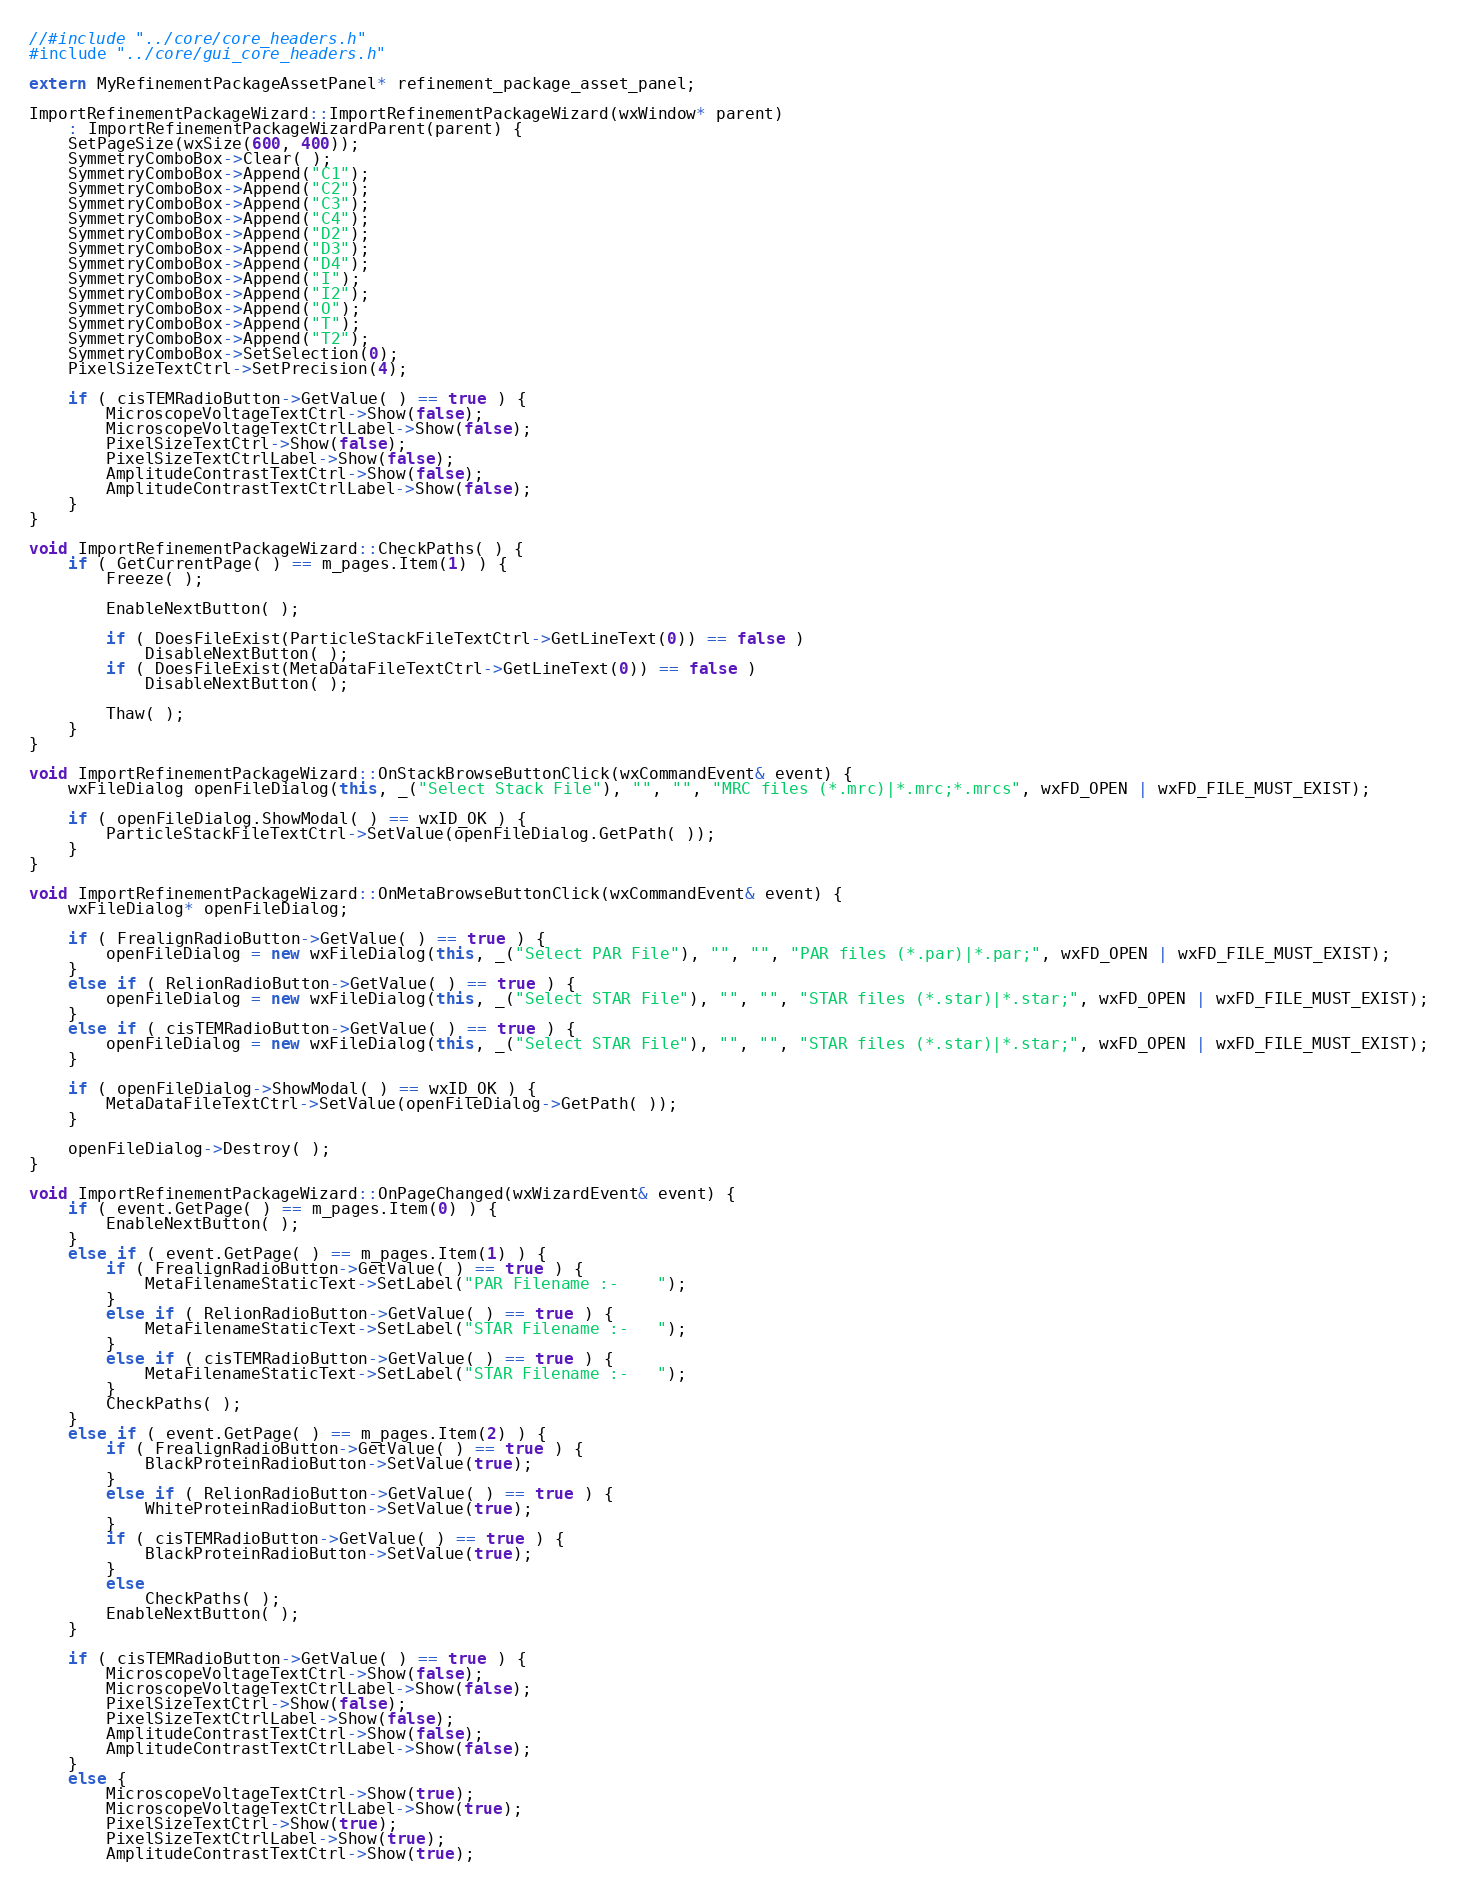Convert code to text. <code><loc_0><loc_0><loc_500><loc_500><_C++_>//#include "../core/core_headers.h"
#include "../core/gui_core_headers.h"

extern MyRefinementPackageAssetPanel* refinement_package_asset_panel;

ImportRefinementPackageWizard::ImportRefinementPackageWizard(wxWindow* parent)
    : ImportRefinementPackageWizardParent(parent) {
    SetPageSize(wxSize(600, 400));
    SymmetryComboBox->Clear( );
    SymmetryComboBox->Append("C1");
    SymmetryComboBox->Append("C2");
    SymmetryComboBox->Append("C3");
    SymmetryComboBox->Append("C4");
    SymmetryComboBox->Append("D2");
    SymmetryComboBox->Append("D3");
    SymmetryComboBox->Append("D4");
    SymmetryComboBox->Append("I");
    SymmetryComboBox->Append("I2");
    SymmetryComboBox->Append("O");
    SymmetryComboBox->Append("T");
    SymmetryComboBox->Append("T2");
    SymmetryComboBox->SetSelection(0);
    PixelSizeTextCtrl->SetPrecision(4);

    if ( cisTEMRadioButton->GetValue( ) == true ) {
        MicroscopeVoltageTextCtrl->Show(false);
        MicroscopeVoltageTextCtrlLabel->Show(false);
        PixelSizeTextCtrl->Show(false);
        PixelSizeTextCtrlLabel->Show(false);
        AmplitudeContrastTextCtrl->Show(false);
        AmplitudeContrastTextCtrlLabel->Show(false);
    }
}

void ImportRefinementPackageWizard::CheckPaths( ) {
    if ( GetCurrentPage( ) == m_pages.Item(1) ) {
        Freeze( );

        EnableNextButton( );

        if ( DoesFileExist(ParticleStackFileTextCtrl->GetLineText(0)) == false )
            DisableNextButton( );
        if ( DoesFileExist(MetaDataFileTextCtrl->GetLineText(0)) == false )
            DisableNextButton( );

        Thaw( );
    }
}

void ImportRefinementPackageWizard::OnStackBrowseButtonClick(wxCommandEvent& event) {
    wxFileDialog openFileDialog(this, _("Select Stack File"), "", "", "MRC files (*.mrc)|*.mrc;*.mrcs", wxFD_OPEN | wxFD_FILE_MUST_EXIST);

    if ( openFileDialog.ShowModal( ) == wxID_OK ) {
        ParticleStackFileTextCtrl->SetValue(openFileDialog.GetPath( ));
    }
}

void ImportRefinementPackageWizard::OnMetaBrowseButtonClick(wxCommandEvent& event) {
    wxFileDialog* openFileDialog;

    if ( FrealignRadioButton->GetValue( ) == true ) {
        openFileDialog = new wxFileDialog(this, _("Select PAR File"), "", "", "PAR files (*.par)|*.par;", wxFD_OPEN | wxFD_FILE_MUST_EXIST);
    }
    else if ( RelionRadioButton->GetValue( ) == true ) {
        openFileDialog = new wxFileDialog(this, _("Select STAR File"), "", "", "STAR files (*.star)|*.star;", wxFD_OPEN | wxFD_FILE_MUST_EXIST);
    }
    else if ( cisTEMRadioButton->GetValue( ) == true ) {
        openFileDialog = new wxFileDialog(this, _("Select STAR File"), "", "", "STAR files (*.star)|*.star;", wxFD_OPEN | wxFD_FILE_MUST_EXIST);
    }

    if ( openFileDialog->ShowModal( ) == wxID_OK ) {
        MetaDataFileTextCtrl->SetValue(openFileDialog->GetPath( ));
    }

    openFileDialog->Destroy( );
}

void ImportRefinementPackageWizard::OnPageChanged(wxWizardEvent& event) {
    if ( event.GetPage( ) == m_pages.Item(0) ) {
        EnableNextButton( );
    }
    else if ( event.GetPage( ) == m_pages.Item(1) ) {
        if ( FrealignRadioButton->GetValue( ) == true ) {
            MetaFilenameStaticText->SetLabel("PAR Filename :-    ");
        }
        else if ( RelionRadioButton->GetValue( ) == true ) {
            MetaFilenameStaticText->SetLabel("STAR Filename :-   ");
        }
        else if ( cisTEMRadioButton->GetValue( ) == true ) {
            MetaFilenameStaticText->SetLabel("STAR Filename :-   ");
        }
        CheckPaths( );
    }
    else if ( event.GetPage( ) == m_pages.Item(2) ) {
        if ( FrealignRadioButton->GetValue( ) == true ) {
            BlackProteinRadioButton->SetValue(true);
        }
        else if ( RelionRadioButton->GetValue( ) == true ) {
            WhiteProteinRadioButton->SetValue(true);
        }
        if ( cisTEMRadioButton->GetValue( ) == true ) {
            BlackProteinRadioButton->SetValue(true);
        }
        else
            CheckPaths( );
        EnableNextButton( );
    }

    if ( cisTEMRadioButton->GetValue( ) == true ) {
        MicroscopeVoltageTextCtrl->Show(false);
        MicroscopeVoltageTextCtrlLabel->Show(false);
        PixelSizeTextCtrl->Show(false);
        PixelSizeTextCtrlLabel->Show(false);
        AmplitudeContrastTextCtrl->Show(false);
        AmplitudeContrastTextCtrlLabel->Show(false);
    }
    else {
        MicroscopeVoltageTextCtrl->Show(true);
        MicroscopeVoltageTextCtrlLabel->Show(true);
        PixelSizeTextCtrl->Show(true);
        PixelSizeTextCtrlLabel->Show(true);
        AmplitudeContrastTextCtrl->Show(true);</code> 